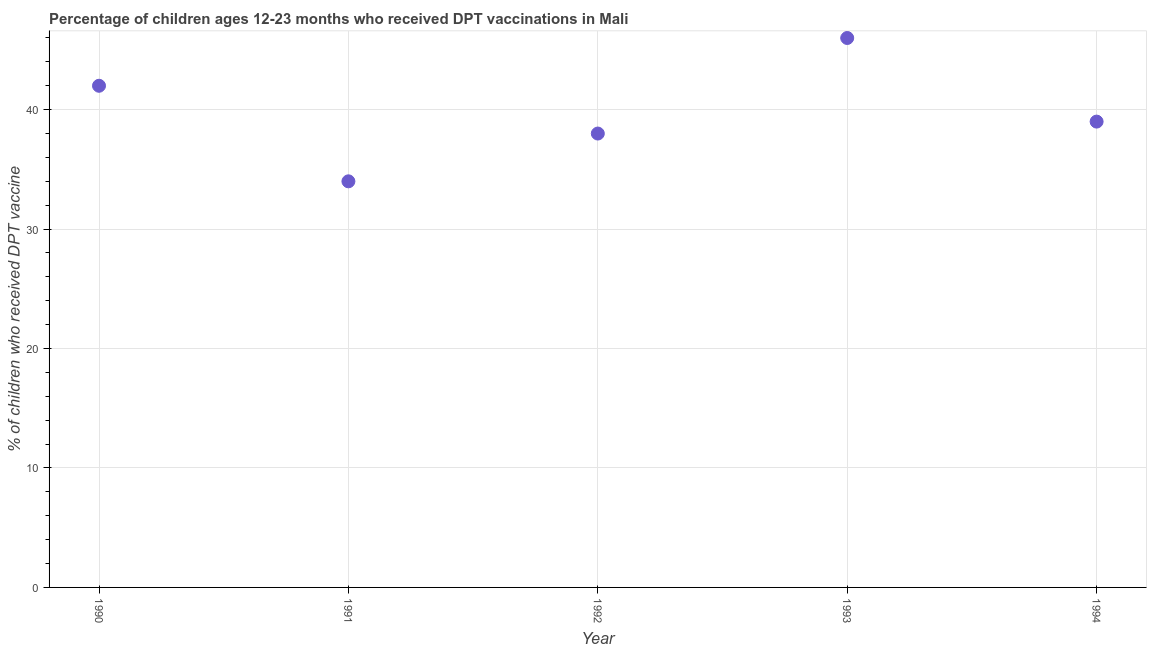What is the percentage of children who received dpt vaccine in 1991?
Provide a short and direct response. 34. Across all years, what is the maximum percentage of children who received dpt vaccine?
Make the answer very short. 46. Across all years, what is the minimum percentage of children who received dpt vaccine?
Make the answer very short. 34. In which year was the percentage of children who received dpt vaccine maximum?
Offer a terse response. 1993. What is the sum of the percentage of children who received dpt vaccine?
Offer a terse response. 199. What is the difference between the percentage of children who received dpt vaccine in 1990 and 1994?
Your answer should be very brief. 3. What is the average percentage of children who received dpt vaccine per year?
Your answer should be very brief. 39.8. In how many years, is the percentage of children who received dpt vaccine greater than 40 %?
Offer a terse response. 2. Do a majority of the years between 1993 and 1994 (inclusive) have percentage of children who received dpt vaccine greater than 24 %?
Ensure brevity in your answer.  Yes. What is the ratio of the percentage of children who received dpt vaccine in 1990 to that in 1991?
Your answer should be compact. 1.24. Is the percentage of children who received dpt vaccine in 1992 less than that in 1994?
Keep it short and to the point. Yes. Is the difference between the percentage of children who received dpt vaccine in 1991 and 1993 greater than the difference between any two years?
Your answer should be very brief. Yes. What is the difference between the highest and the second highest percentage of children who received dpt vaccine?
Ensure brevity in your answer.  4. Is the sum of the percentage of children who received dpt vaccine in 1992 and 1993 greater than the maximum percentage of children who received dpt vaccine across all years?
Provide a short and direct response. Yes. What is the difference between the highest and the lowest percentage of children who received dpt vaccine?
Offer a terse response. 12. In how many years, is the percentage of children who received dpt vaccine greater than the average percentage of children who received dpt vaccine taken over all years?
Keep it short and to the point. 2. Does the percentage of children who received dpt vaccine monotonically increase over the years?
Offer a very short reply. No. How many dotlines are there?
Provide a short and direct response. 1. How many years are there in the graph?
Offer a terse response. 5. Are the values on the major ticks of Y-axis written in scientific E-notation?
Provide a short and direct response. No. Does the graph contain grids?
Make the answer very short. Yes. What is the title of the graph?
Make the answer very short. Percentage of children ages 12-23 months who received DPT vaccinations in Mali. What is the label or title of the X-axis?
Your response must be concise. Year. What is the label or title of the Y-axis?
Offer a terse response. % of children who received DPT vaccine. What is the % of children who received DPT vaccine in 1991?
Ensure brevity in your answer.  34. What is the % of children who received DPT vaccine in 1994?
Provide a succinct answer. 39. What is the difference between the % of children who received DPT vaccine in 1990 and 1993?
Provide a short and direct response. -4. What is the difference between the % of children who received DPT vaccine in 1991 and 1992?
Provide a succinct answer. -4. What is the difference between the % of children who received DPT vaccine in 1991 and 1993?
Your answer should be compact. -12. What is the difference between the % of children who received DPT vaccine in 1992 and 1993?
Your response must be concise. -8. What is the difference between the % of children who received DPT vaccine in 1992 and 1994?
Your response must be concise. -1. What is the difference between the % of children who received DPT vaccine in 1993 and 1994?
Offer a very short reply. 7. What is the ratio of the % of children who received DPT vaccine in 1990 to that in 1991?
Make the answer very short. 1.24. What is the ratio of the % of children who received DPT vaccine in 1990 to that in 1992?
Offer a terse response. 1.1. What is the ratio of the % of children who received DPT vaccine in 1990 to that in 1993?
Give a very brief answer. 0.91. What is the ratio of the % of children who received DPT vaccine in 1990 to that in 1994?
Keep it short and to the point. 1.08. What is the ratio of the % of children who received DPT vaccine in 1991 to that in 1992?
Make the answer very short. 0.9. What is the ratio of the % of children who received DPT vaccine in 1991 to that in 1993?
Your answer should be compact. 0.74. What is the ratio of the % of children who received DPT vaccine in 1991 to that in 1994?
Your answer should be very brief. 0.87. What is the ratio of the % of children who received DPT vaccine in 1992 to that in 1993?
Offer a very short reply. 0.83. What is the ratio of the % of children who received DPT vaccine in 1993 to that in 1994?
Provide a succinct answer. 1.18. 